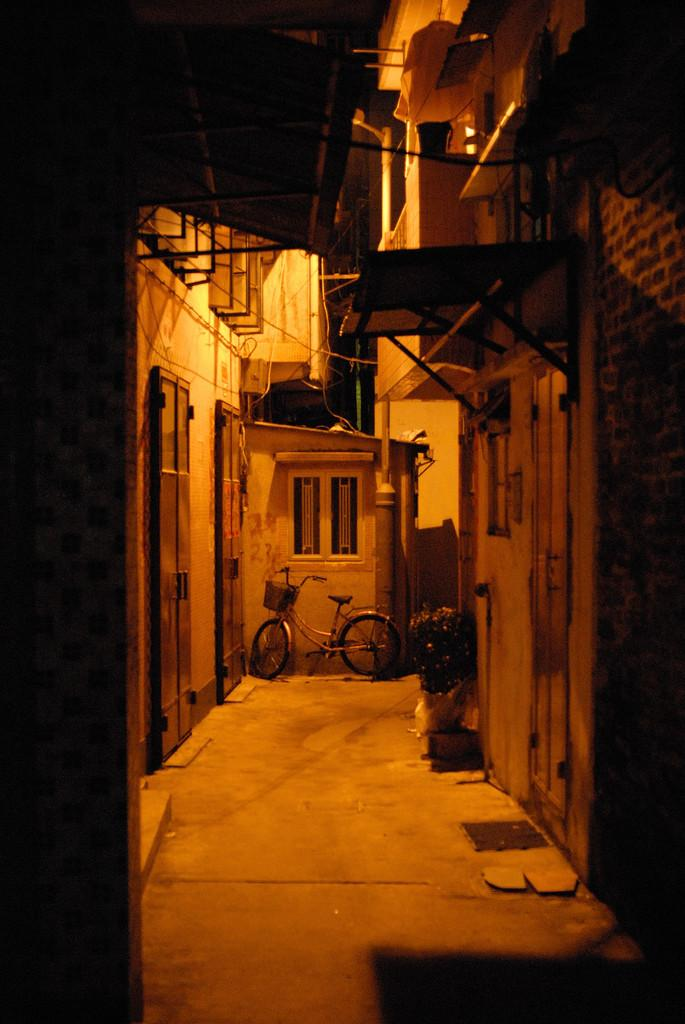What is the main subject in the center of the image? There is a bicycle in the center of the image. Are there any other objects or plants in the image? Yes, there is a houseplant in the image. What can be seen in the background of the image? There are buildings and rods visible in the background of the image. How many fingers can be seen on the bicycle in the image? There are no fingers visible on the bicycle in the image. 